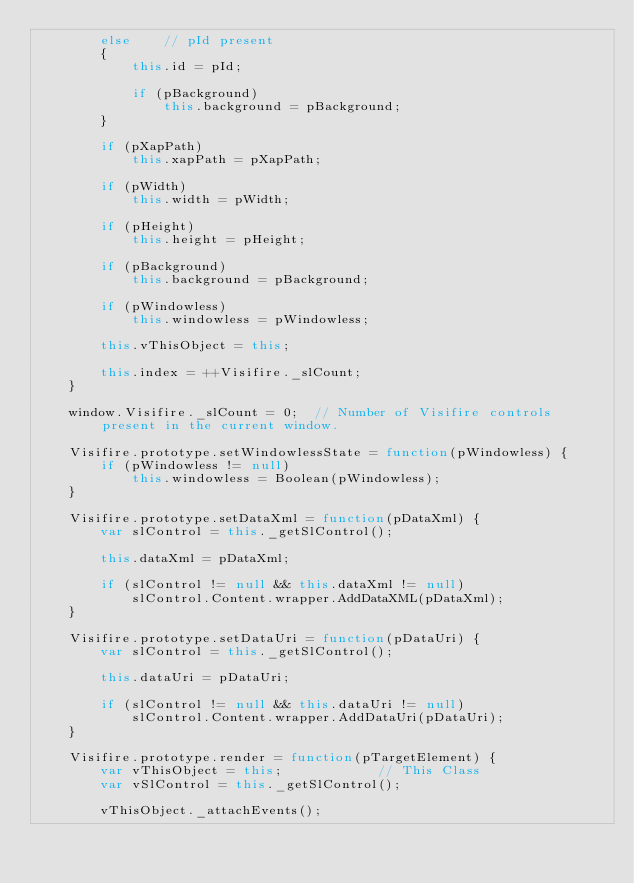<code> <loc_0><loc_0><loc_500><loc_500><_JavaScript_>        else    // pId present
        {
            this.id = pId;

            if (pBackground)
                this.background = pBackground;
        }

        if (pXapPath)
            this.xapPath = pXapPath;

        if (pWidth)
            this.width = pWidth;

        if (pHeight)
            this.height = pHeight;

        if (pBackground)
            this.background = pBackground;

        if (pWindowless)
            this.windowless = pWindowless;

        this.vThisObject = this;

        this.index = ++Visifire._slCount;
    }

    window.Visifire._slCount = 0;  // Number of Visifire controls present in the current window.

    Visifire.prototype.setWindowlessState = function(pWindowless) {
        if (pWindowless != null)
            this.windowless = Boolean(pWindowless);
    }

    Visifire.prototype.setDataXml = function(pDataXml) {
        var slControl = this._getSlControl();

        this.dataXml = pDataXml;
        
        if (slControl != null && this.dataXml != null)
            slControl.Content.wrapper.AddDataXML(pDataXml);
    }

    Visifire.prototype.setDataUri = function(pDataUri) {
        var slControl = this._getSlControl();

        this.dataUri = pDataUri;

        if (slControl != null && this.dataUri != null)
            slControl.Content.wrapper.AddDataUri(pDataUri);
    }

    Visifire.prototype.render = function(pTargetElement) {
        var vThisObject = this;            // This Class
        var vSlControl = this._getSlControl();

        vThisObject._attachEvents();</code> 